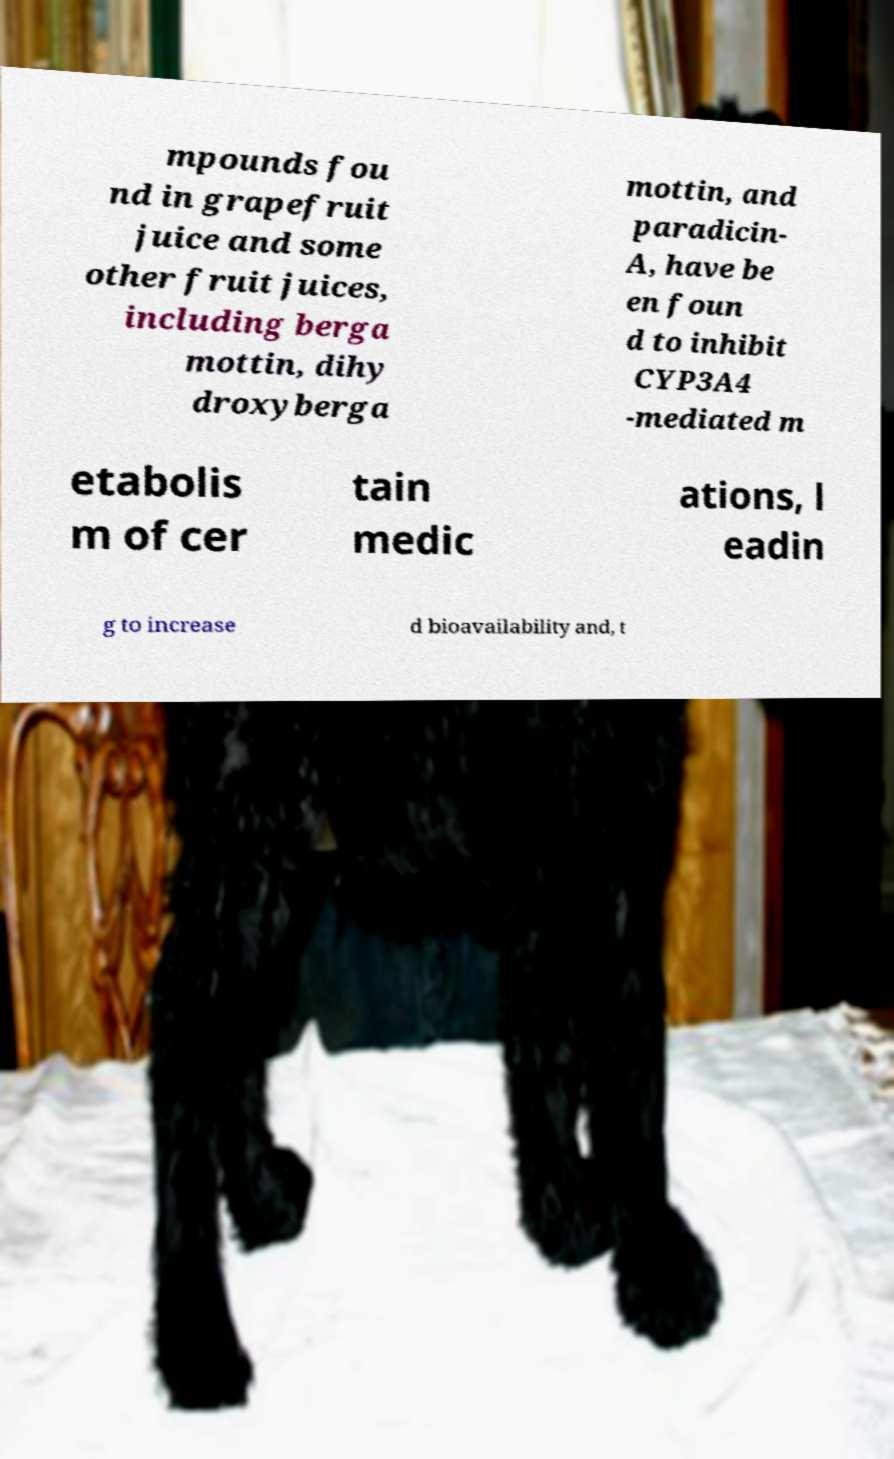Could you assist in decoding the text presented in this image and type it out clearly? mpounds fou nd in grapefruit juice and some other fruit juices, including berga mottin, dihy droxyberga mottin, and paradicin- A, have be en foun d to inhibit CYP3A4 -mediated m etabolis m of cer tain medic ations, l eadin g to increase d bioavailability and, t 